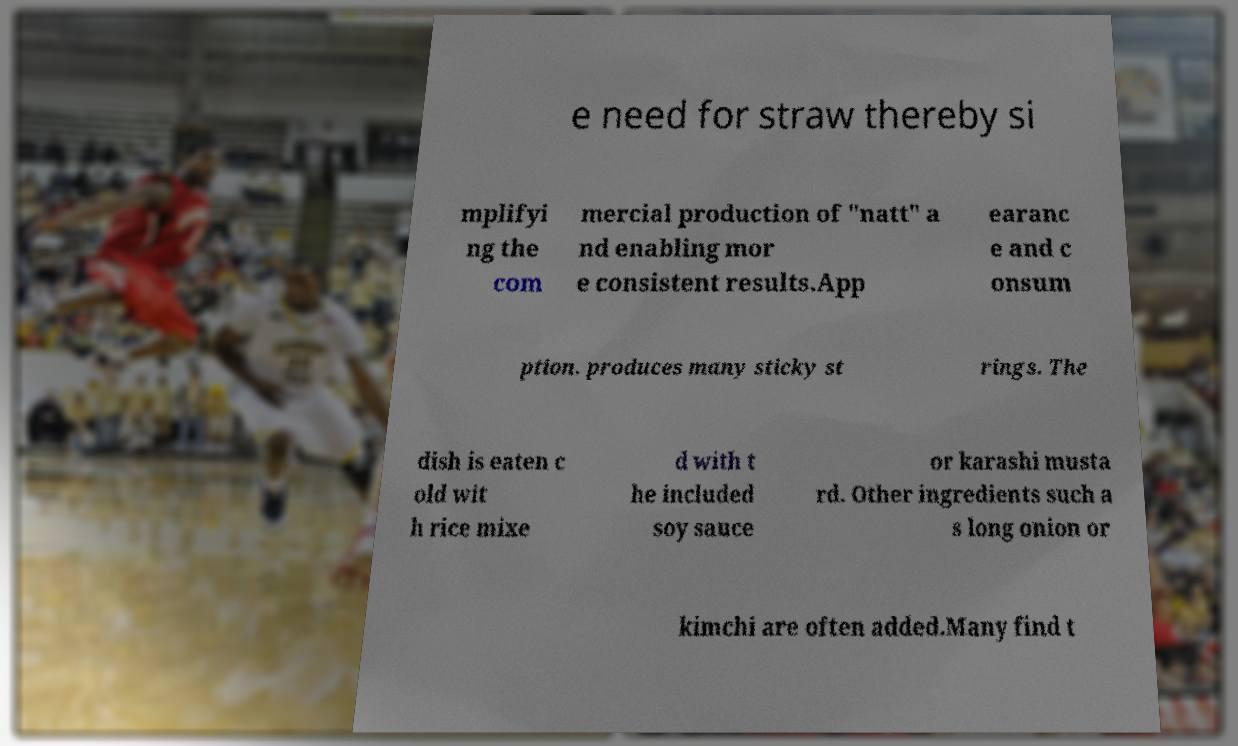Could you assist in decoding the text presented in this image and type it out clearly? e need for straw thereby si mplifyi ng the com mercial production of "natt" a nd enabling mor e consistent results.App earanc e and c onsum ption. produces many sticky st rings. The dish is eaten c old wit h rice mixe d with t he included soy sauce or karashi musta rd. Other ingredients such a s long onion or kimchi are often added.Many find t 